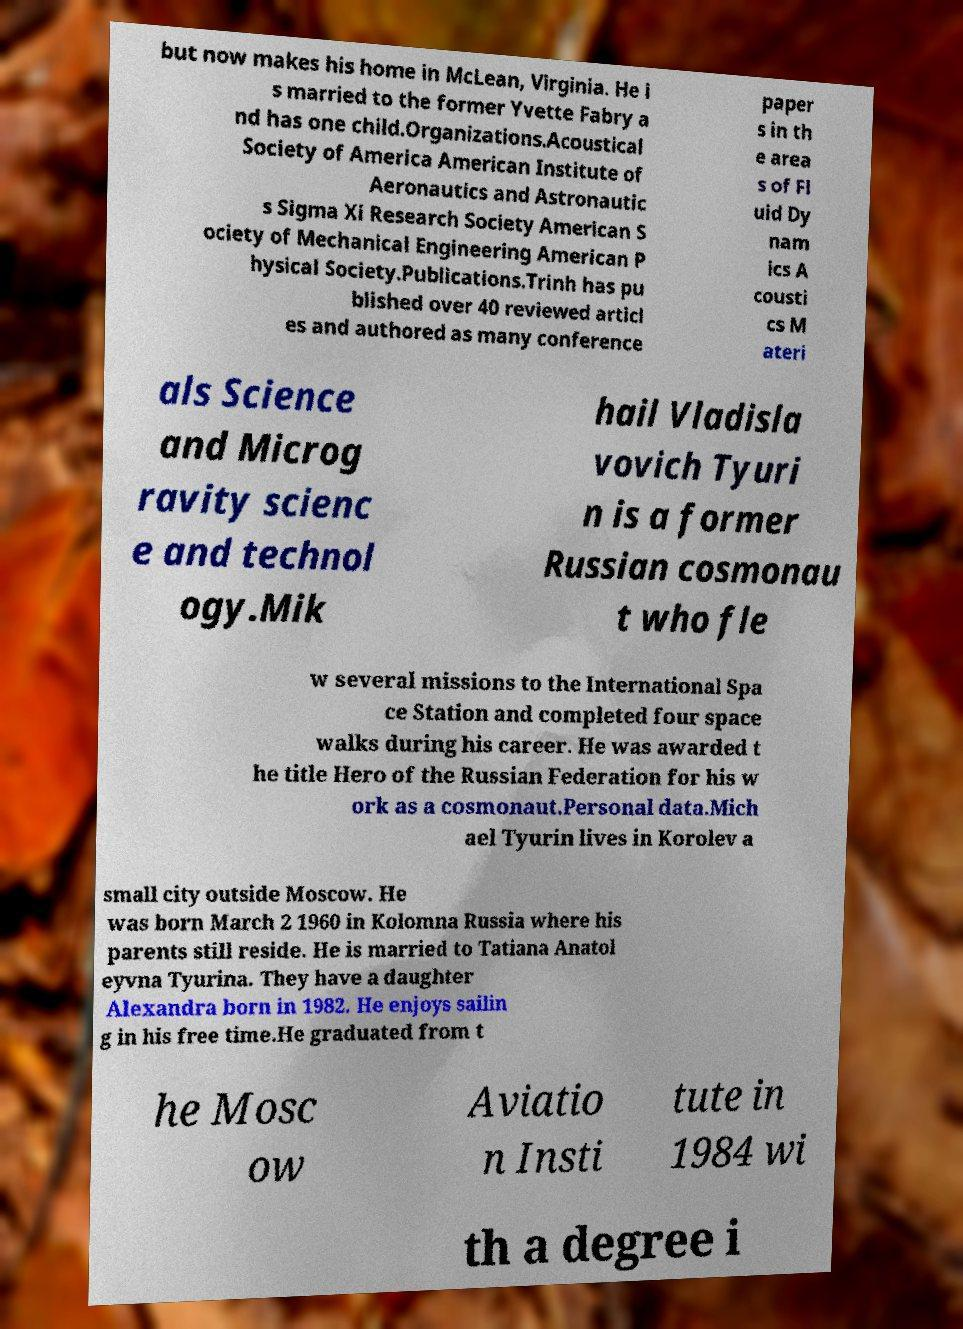Can you read and provide the text displayed in the image?This photo seems to have some interesting text. Can you extract and type it out for me? but now makes his home in McLean, Virginia. He i s married to the former Yvette Fabry a nd has one child.Organizations.Acoustical Society of America American Institute of Aeronautics and Astronautic s Sigma Xi Research Society American S ociety of Mechanical Engineering American P hysical Society.Publications.Trinh has pu blished over 40 reviewed articl es and authored as many conference paper s in th e area s of Fl uid Dy nam ics A cousti cs M ateri als Science and Microg ravity scienc e and technol ogy.Mik hail Vladisla vovich Tyuri n is a former Russian cosmonau t who fle w several missions to the International Spa ce Station and completed four space walks during his career. He was awarded t he title Hero of the Russian Federation for his w ork as a cosmonaut.Personal data.Mich ael Tyurin lives in Korolev a small city outside Moscow. He was born March 2 1960 in Kolomna Russia where his parents still reside. He is married to Tatiana Anatol eyvna Tyurina. They have a daughter Alexandra born in 1982. He enjoys sailin g in his free time.He graduated from t he Mosc ow Aviatio n Insti tute in 1984 wi th a degree i 